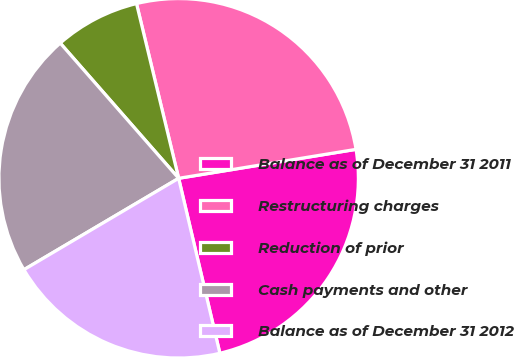Convert chart to OTSL. <chart><loc_0><loc_0><loc_500><loc_500><pie_chart><fcel>Balance as of December 31 2011<fcel>Restructuring charges<fcel>Reduction of prior<fcel>Cash payments and other<fcel>Balance as of December 31 2012<nl><fcel>23.89%<fcel>26.19%<fcel>7.68%<fcel>22.04%<fcel>20.19%<nl></chart> 